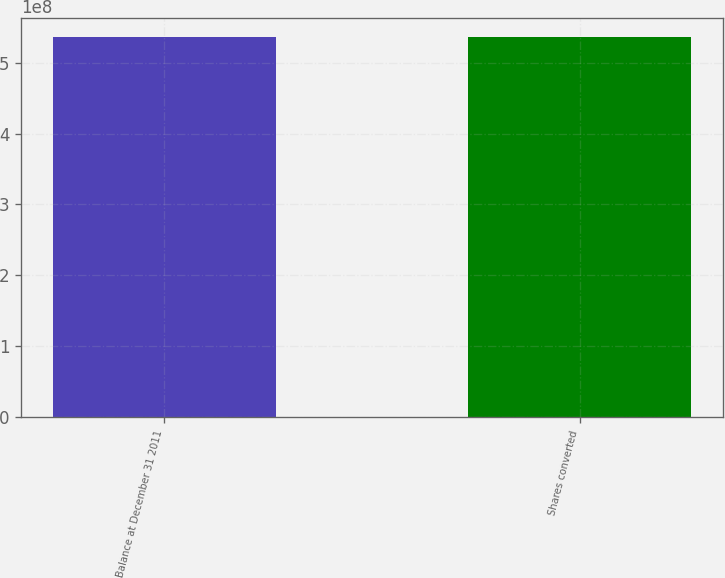<chart> <loc_0><loc_0><loc_500><loc_500><bar_chart><fcel>Balance at December 31 2011<fcel>Shares converted<nl><fcel>5.35972e+08<fcel>5.35972e+08<nl></chart> 